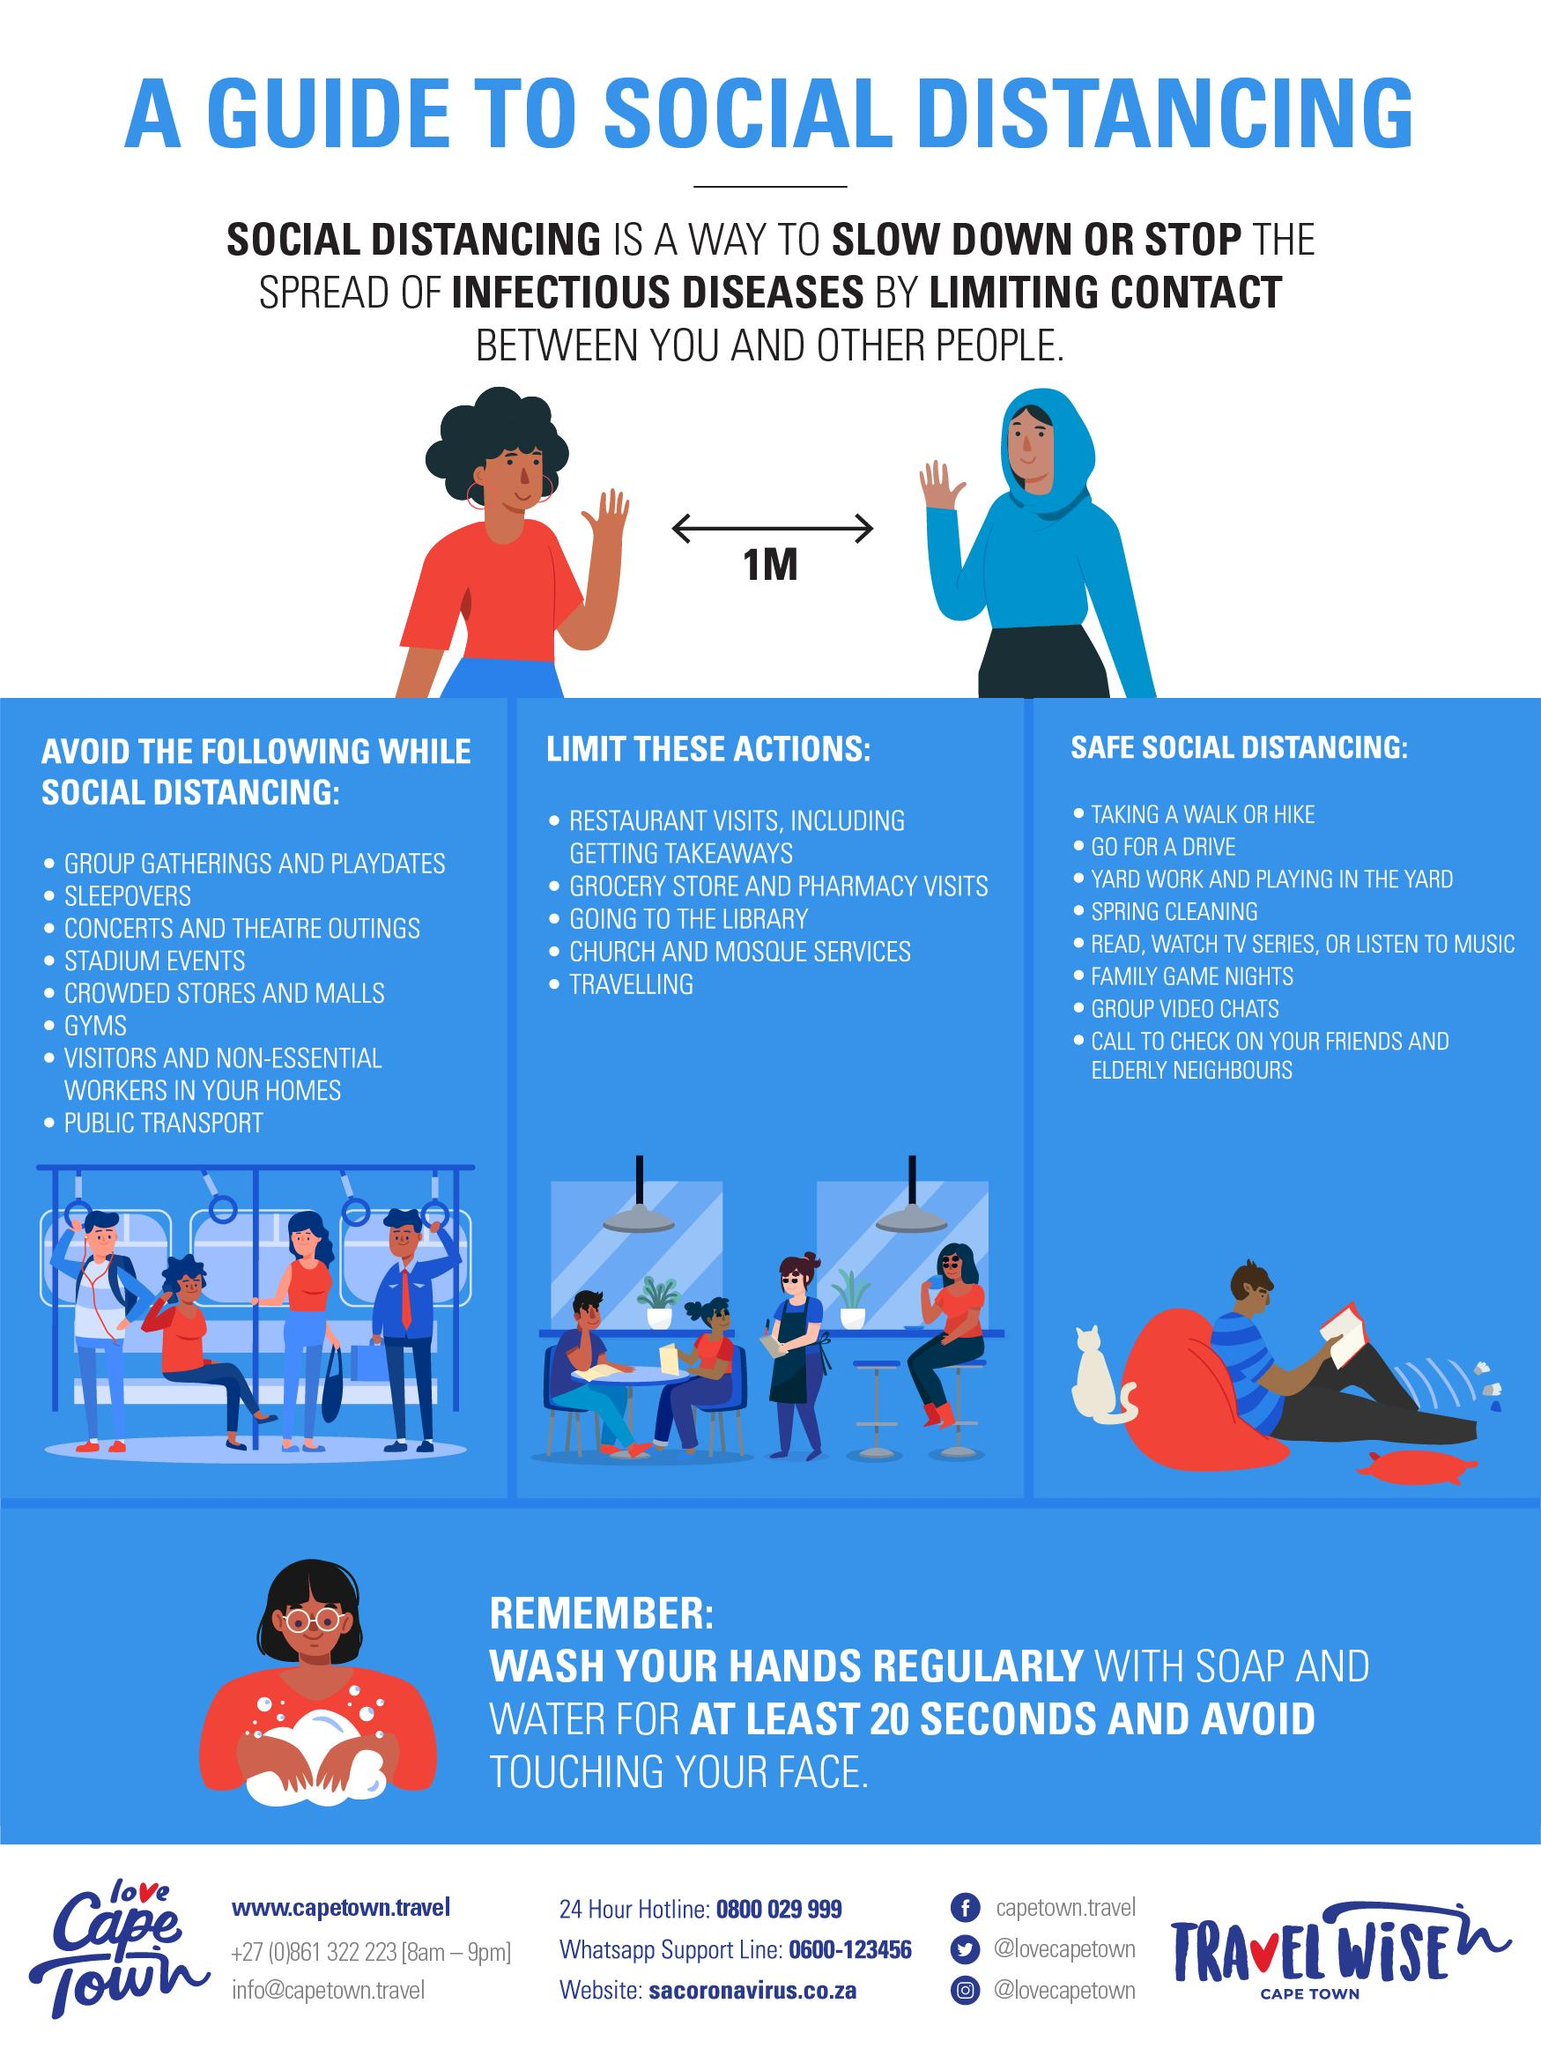Draw attention to some important aspects in this diagram. The minimum safe distance to be maintained between oneself and others in order to control the spread of COVID-19 virus is one meter. 